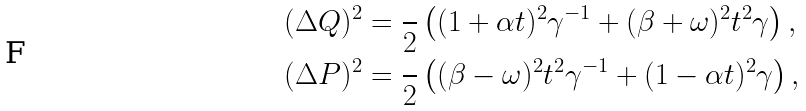<formula> <loc_0><loc_0><loc_500><loc_500>( \Delta Q ) ^ { 2 } & = \frac { } { 2 } \left ( ( 1 + \alpha t ) ^ { 2 } \gamma ^ { - 1 } + ( \beta + \omega ) ^ { 2 } t ^ { 2 } \gamma \right ) , \\ ( \Delta P ) ^ { 2 } & = \frac { } { 2 } \left ( ( \beta - \omega ) ^ { 2 } t ^ { 2 } \gamma ^ { - 1 } + ( 1 - \alpha t ) ^ { 2 } \gamma \right ) ,</formula> 